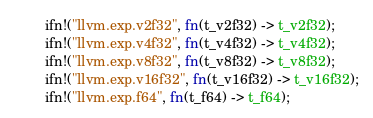Convert code to text. <code><loc_0><loc_0><loc_500><loc_500><_Rust_>        ifn!("llvm.exp.v2f32", fn(t_v2f32) -> t_v2f32);
        ifn!("llvm.exp.v4f32", fn(t_v4f32) -> t_v4f32);
        ifn!("llvm.exp.v8f32", fn(t_v8f32) -> t_v8f32);
        ifn!("llvm.exp.v16f32", fn(t_v16f32) -> t_v16f32);
        ifn!("llvm.exp.f64", fn(t_f64) -> t_f64);</code> 